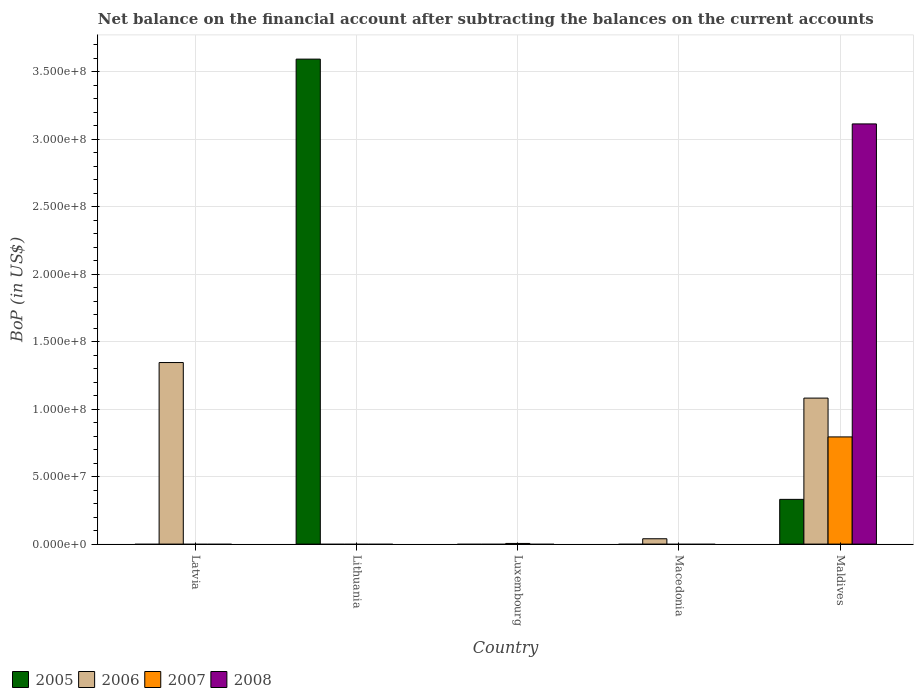Are the number of bars per tick equal to the number of legend labels?
Provide a short and direct response. No. How many bars are there on the 5th tick from the right?
Provide a short and direct response. 1. What is the label of the 1st group of bars from the left?
Give a very brief answer. Latvia. In how many cases, is the number of bars for a given country not equal to the number of legend labels?
Provide a succinct answer. 4. What is the Balance of Payments in 2005 in Lithuania?
Ensure brevity in your answer.  3.60e+08. Across all countries, what is the maximum Balance of Payments in 2008?
Ensure brevity in your answer.  3.11e+08. Across all countries, what is the minimum Balance of Payments in 2008?
Your answer should be compact. 0. In which country was the Balance of Payments in 2008 maximum?
Provide a short and direct response. Maldives. What is the total Balance of Payments in 2006 in the graph?
Provide a succinct answer. 2.47e+08. What is the difference between the Balance of Payments in 2006 in Latvia and the Balance of Payments in 2007 in Luxembourg?
Offer a terse response. 1.34e+08. What is the average Balance of Payments in 2006 per country?
Provide a succinct answer. 4.94e+07. What is the difference between the Balance of Payments of/in 2005 and Balance of Payments of/in 2007 in Maldives?
Give a very brief answer. -4.63e+07. What is the ratio of the Balance of Payments in 2006 in Macedonia to that in Maldives?
Provide a succinct answer. 0.04. What is the difference between the highest and the second highest Balance of Payments in 2006?
Your answer should be compact. -1.04e+08. What is the difference between the highest and the lowest Balance of Payments in 2008?
Offer a terse response. 3.11e+08. In how many countries, is the Balance of Payments in 2005 greater than the average Balance of Payments in 2005 taken over all countries?
Ensure brevity in your answer.  1. Is it the case that in every country, the sum of the Balance of Payments in 2008 and Balance of Payments in 2005 is greater than the sum of Balance of Payments in 2007 and Balance of Payments in 2006?
Your response must be concise. No. Is it the case that in every country, the sum of the Balance of Payments in 2007 and Balance of Payments in 2006 is greater than the Balance of Payments in 2005?
Your answer should be very brief. No. Are all the bars in the graph horizontal?
Keep it short and to the point. No. What is the difference between two consecutive major ticks on the Y-axis?
Ensure brevity in your answer.  5.00e+07. Are the values on the major ticks of Y-axis written in scientific E-notation?
Provide a short and direct response. Yes. Does the graph contain any zero values?
Provide a succinct answer. Yes. Where does the legend appear in the graph?
Offer a terse response. Bottom left. How many legend labels are there?
Offer a very short reply. 4. What is the title of the graph?
Make the answer very short. Net balance on the financial account after subtracting the balances on the current accounts. Does "1983" appear as one of the legend labels in the graph?
Provide a succinct answer. No. What is the label or title of the Y-axis?
Your answer should be compact. BoP (in US$). What is the BoP (in US$) of 2005 in Latvia?
Keep it short and to the point. 0. What is the BoP (in US$) in 2006 in Latvia?
Your answer should be very brief. 1.35e+08. What is the BoP (in US$) of 2005 in Lithuania?
Offer a terse response. 3.60e+08. What is the BoP (in US$) of 2006 in Lithuania?
Provide a short and direct response. 0. What is the BoP (in US$) in 2005 in Luxembourg?
Make the answer very short. 0. What is the BoP (in US$) of 2006 in Luxembourg?
Your answer should be very brief. 0. What is the BoP (in US$) of 2007 in Luxembourg?
Your response must be concise. 4.90e+05. What is the BoP (in US$) in 2005 in Macedonia?
Offer a terse response. 0. What is the BoP (in US$) of 2006 in Macedonia?
Your response must be concise. 3.96e+06. What is the BoP (in US$) of 2005 in Maldives?
Offer a terse response. 3.32e+07. What is the BoP (in US$) in 2006 in Maldives?
Offer a terse response. 1.08e+08. What is the BoP (in US$) of 2007 in Maldives?
Make the answer very short. 7.95e+07. What is the BoP (in US$) of 2008 in Maldives?
Offer a very short reply. 3.11e+08. Across all countries, what is the maximum BoP (in US$) in 2005?
Your answer should be compact. 3.60e+08. Across all countries, what is the maximum BoP (in US$) of 2006?
Give a very brief answer. 1.35e+08. Across all countries, what is the maximum BoP (in US$) in 2007?
Your answer should be compact. 7.95e+07. Across all countries, what is the maximum BoP (in US$) in 2008?
Ensure brevity in your answer.  3.11e+08. Across all countries, what is the minimum BoP (in US$) of 2005?
Your answer should be very brief. 0. Across all countries, what is the minimum BoP (in US$) of 2008?
Give a very brief answer. 0. What is the total BoP (in US$) of 2005 in the graph?
Provide a succinct answer. 3.93e+08. What is the total BoP (in US$) in 2006 in the graph?
Make the answer very short. 2.47e+08. What is the total BoP (in US$) in 2007 in the graph?
Your response must be concise. 8.00e+07. What is the total BoP (in US$) in 2008 in the graph?
Provide a short and direct response. 3.11e+08. What is the difference between the BoP (in US$) of 2006 in Latvia and that in Macedonia?
Offer a terse response. 1.31e+08. What is the difference between the BoP (in US$) in 2006 in Latvia and that in Maldives?
Your answer should be compact. 2.64e+07. What is the difference between the BoP (in US$) in 2005 in Lithuania and that in Maldives?
Offer a terse response. 3.26e+08. What is the difference between the BoP (in US$) of 2007 in Luxembourg and that in Maldives?
Offer a terse response. -7.90e+07. What is the difference between the BoP (in US$) of 2006 in Macedonia and that in Maldives?
Your answer should be compact. -1.04e+08. What is the difference between the BoP (in US$) in 2006 in Latvia and the BoP (in US$) in 2007 in Luxembourg?
Your answer should be very brief. 1.34e+08. What is the difference between the BoP (in US$) of 2006 in Latvia and the BoP (in US$) of 2007 in Maldives?
Your response must be concise. 5.51e+07. What is the difference between the BoP (in US$) in 2006 in Latvia and the BoP (in US$) in 2008 in Maldives?
Provide a succinct answer. -1.77e+08. What is the difference between the BoP (in US$) of 2005 in Lithuania and the BoP (in US$) of 2007 in Luxembourg?
Make the answer very short. 3.59e+08. What is the difference between the BoP (in US$) of 2005 in Lithuania and the BoP (in US$) of 2006 in Macedonia?
Ensure brevity in your answer.  3.56e+08. What is the difference between the BoP (in US$) in 2005 in Lithuania and the BoP (in US$) in 2006 in Maldives?
Make the answer very short. 2.51e+08. What is the difference between the BoP (in US$) of 2005 in Lithuania and the BoP (in US$) of 2007 in Maldives?
Make the answer very short. 2.80e+08. What is the difference between the BoP (in US$) in 2005 in Lithuania and the BoP (in US$) in 2008 in Maldives?
Your answer should be very brief. 4.80e+07. What is the difference between the BoP (in US$) in 2007 in Luxembourg and the BoP (in US$) in 2008 in Maldives?
Offer a very short reply. -3.11e+08. What is the difference between the BoP (in US$) of 2006 in Macedonia and the BoP (in US$) of 2007 in Maldives?
Offer a very short reply. -7.55e+07. What is the difference between the BoP (in US$) of 2006 in Macedonia and the BoP (in US$) of 2008 in Maldives?
Make the answer very short. -3.08e+08. What is the average BoP (in US$) in 2005 per country?
Offer a terse response. 7.85e+07. What is the average BoP (in US$) of 2006 per country?
Offer a terse response. 4.94e+07. What is the average BoP (in US$) in 2007 per country?
Keep it short and to the point. 1.60e+07. What is the average BoP (in US$) of 2008 per country?
Keep it short and to the point. 6.23e+07. What is the difference between the BoP (in US$) of 2005 and BoP (in US$) of 2006 in Maldives?
Your answer should be very brief. -7.51e+07. What is the difference between the BoP (in US$) of 2005 and BoP (in US$) of 2007 in Maldives?
Provide a short and direct response. -4.63e+07. What is the difference between the BoP (in US$) of 2005 and BoP (in US$) of 2008 in Maldives?
Give a very brief answer. -2.78e+08. What is the difference between the BoP (in US$) of 2006 and BoP (in US$) of 2007 in Maldives?
Ensure brevity in your answer.  2.88e+07. What is the difference between the BoP (in US$) in 2006 and BoP (in US$) in 2008 in Maldives?
Keep it short and to the point. -2.03e+08. What is the difference between the BoP (in US$) in 2007 and BoP (in US$) in 2008 in Maldives?
Keep it short and to the point. -2.32e+08. What is the ratio of the BoP (in US$) of 2006 in Latvia to that in Macedonia?
Offer a terse response. 33.98. What is the ratio of the BoP (in US$) of 2006 in Latvia to that in Maldives?
Your answer should be compact. 1.24. What is the ratio of the BoP (in US$) of 2005 in Lithuania to that in Maldives?
Offer a terse response. 10.84. What is the ratio of the BoP (in US$) in 2007 in Luxembourg to that in Maldives?
Your answer should be compact. 0.01. What is the ratio of the BoP (in US$) in 2006 in Macedonia to that in Maldives?
Offer a terse response. 0.04. What is the difference between the highest and the second highest BoP (in US$) in 2006?
Offer a terse response. 2.64e+07. What is the difference between the highest and the lowest BoP (in US$) in 2005?
Make the answer very short. 3.60e+08. What is the difference between the highest and the lowest BoP (in US$) in 2006?
Your response must be concise. 1.35e+08. What is the difference between the highest and the lowest BoP (in US$) in 2007?
Your answer should be compact. 7.95e+07. What is the difference between the highest and the lowest BoP (in US$) in 2008?
Provide a short and direct response. 3.11e+08. 